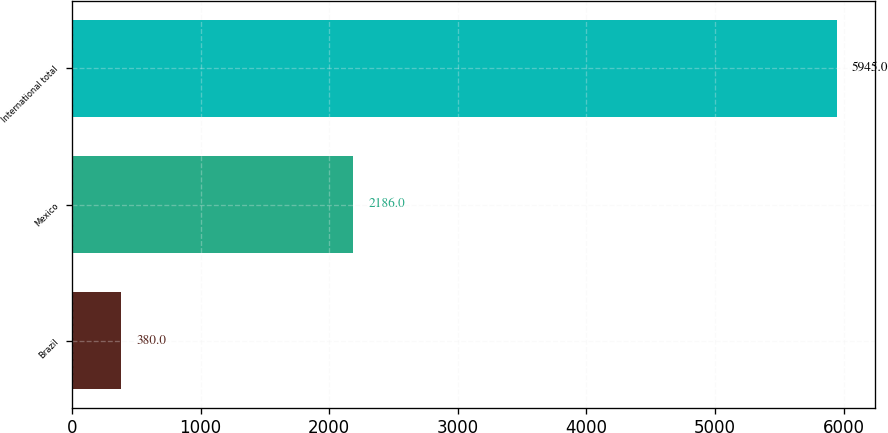<chart> <loc_0><loc_0><loc_500><loc_500><bar_chart><fcel>Brazil<fcel>Mexico<fcel>International total<nl><fcel>380<fcel>2186<fcel>5945<nl></chart> 